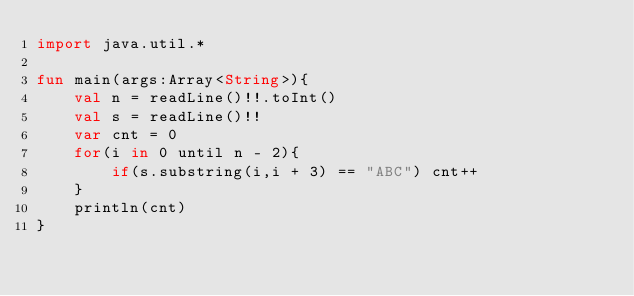Convert code to text. <code><loc_0><loc_0><loc_500><loc_500><_Kotlin_>import java.util.*

fun main(args:Array<String>){
    val n = readLine()!!.toInt()
    val s = readLine()!!
    var cnt = 0
    for(i in 0 until n - 2){
        if(s.substring(i,i + 3) == "ABC") cnt++
    }
    println(cnt)
}
</code> 